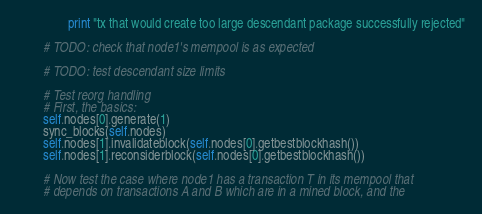<code> <loc_0><loc_0><loc_500><loc_500><_Python_>                print "tx that would create too large descendant package successfully rejected"

        # TODO: check that node1's mempool is as expected

        # TODO: test descendant size limits

        # Test reorg handling
        # First, the basics:
        self.nodes[0].generate(1)
        sync_blocks(self.nodes)
        self.nodes[1].invalidateblock(self.nodes[0].getbestblockhash())
        self.nodes[1].reconsiderblock(self.nodes[0].getbestblockhash())

        # Now test the case where node1 has a transaction T in its mempool that
        # depends on transactions A and B which are in a mined block, and the</code> 